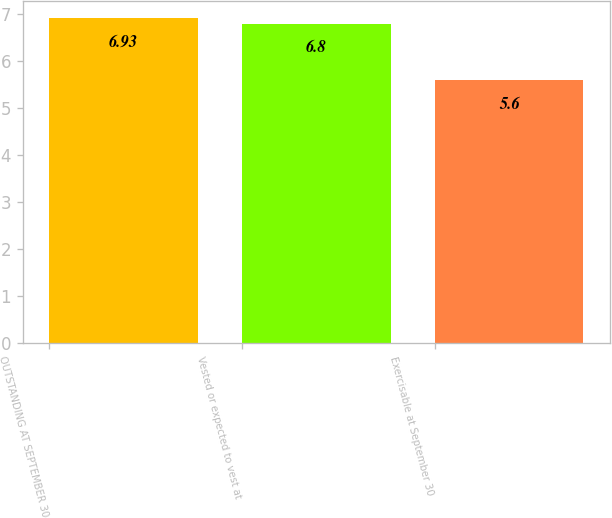<chart> <loc_0><loc_0><loc_500><loc_500><bar_chart><fcel>OUTSTANDING AT SEPTEMBER 30<fcel>Vested or expected to vest at<fcel>Exercisable at September 30<nl><fcel>6.93<fcel>6.8<fcel>5.6<nl></chart> 